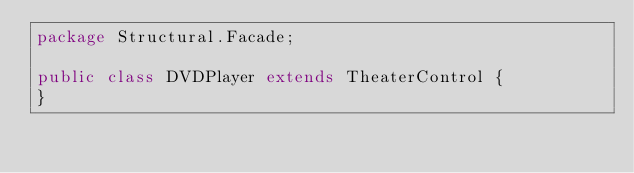<code> <loc_0><loc_0><loc_500><loc_500><_Java_>package Structural.Facade;

public class DVDPlayer extends TheaterControl {
}
</code> 